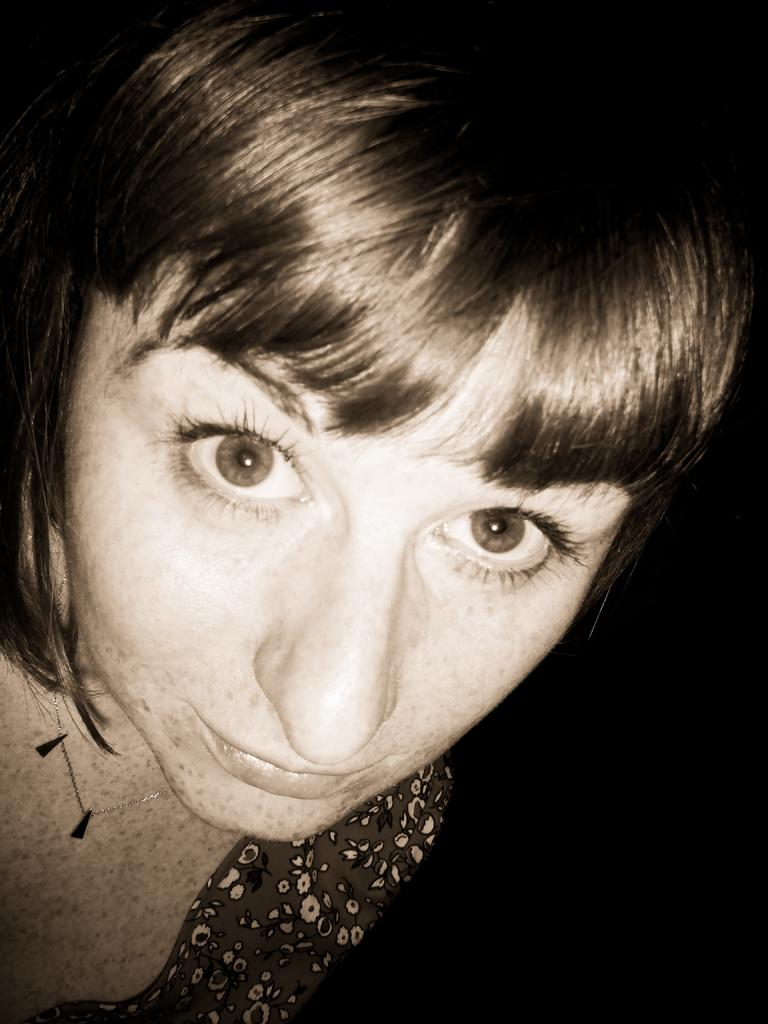What is the color scheme of the image? The image is black and white. How would you describe the background of the image? The background of the image is dark. Can you identify any people in the image? Yes, there is a woman on the left side of the image. What type of pain is the woman experiencing in the image? There is no indication of pain in the image, as it is a black and white photograph of a woman. Can you see any visible veins on the woman's hands in the image? The image is in black and white, so it is difficult to discern the visibility of veins on the woman's hands. Is the woman wearing a mitten in the image? There is no mitten visible on the woman's hands in the image. 